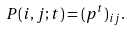Convert formula to latex. <formula><loc_0><loc_0><loc_500><loc_500>P ( i , j ; t ) = ( p ^ { t } ) _ { i j } .</formula> 